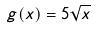<formula> <loc_0><loc_0><loc_500><loc_500>g ( x ) = 5 \sqrt { x }</formula> 